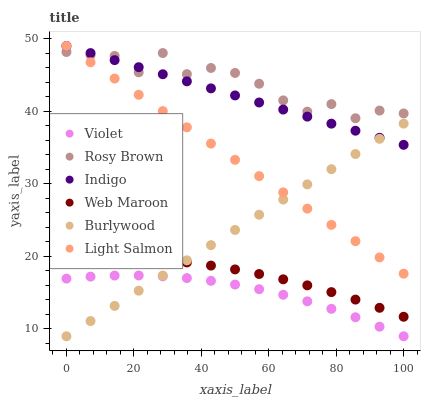Does Violet have the minimum area under the curve?
Answer yes or no. Yes. Does Rosy Brown have the maximum area under the curve?
Answer yes or no. Yes. Does Indigo have the minimum area under the curve?
Answer yes or no. No. Does Indigo have the maximum area under the curve?
Answer yes or no. No. Is Indigo the smoothest?
Answer yes or no. Yes. Is Rosy Brown the roughest?
Answer yes or no. Yes. Is Burlywood the smoothest?
Answer yes or no. No. Is Burlywood the roughest?
Answer yes or no. No. Does Burlywood have the lowest value?
Answer yes or no. Yes. Does Indigo have the lowest value?
Answer yes or no. No. Does Indigo have the highest value?
Answer yes or no. Yes. Does Burlywood have the highest value?
Answer yes or no. No. Is Web Maroon less than Rosy Brown?
Answer yes or no. Yes. Is Indigo greater than Web Maroon?
Answer yes or no. Yes. Does Light Salmon intersect Burlywood?
Answer yes or no. Yes. Is Light Salmon less than Burlywood?
Answer yes or no. No. Is Light Salmon greater than Burlywood?
Answer yes or no. No. Does Web Maroon intersect Rosy Brown?
Answer yes or no. No. 